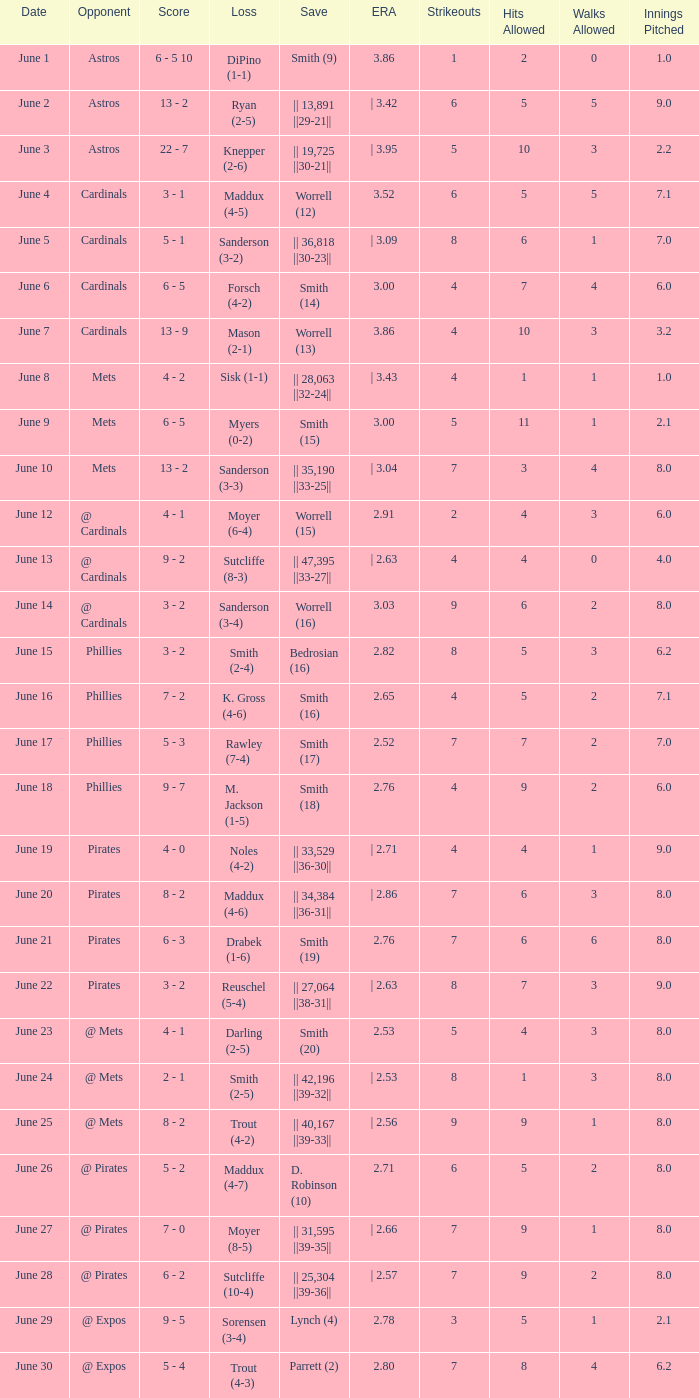The game with a loss of smith (2-4) ended with what score? 3 - 2. 